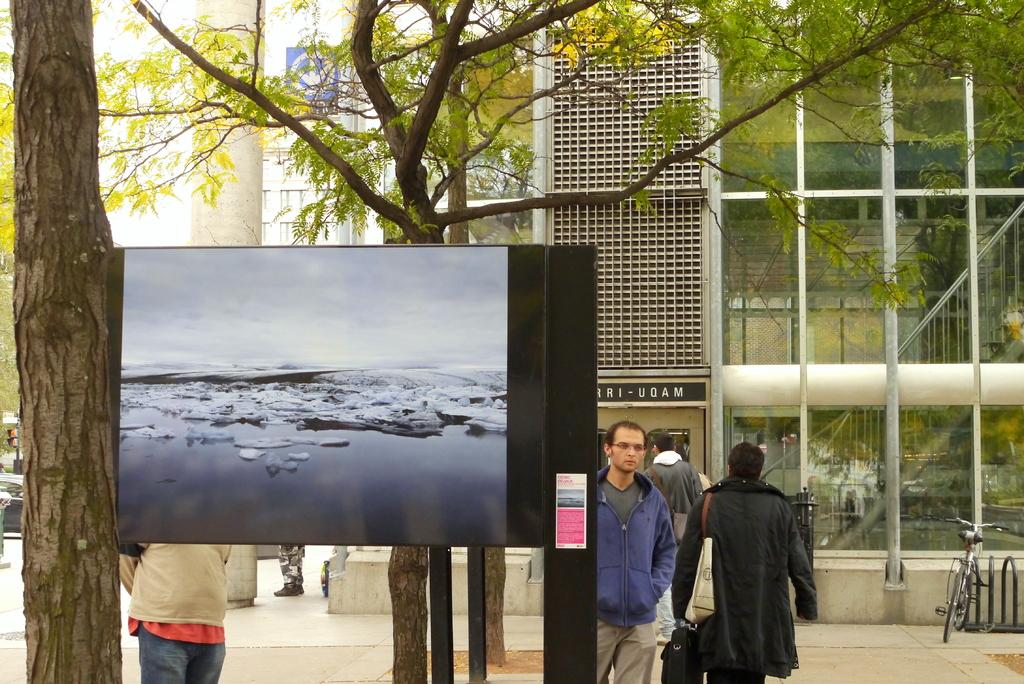How many people are in the image? There are people in the image, but the exact number is not specified. What is the board used for in the image? The purpose of the board in the image is not clear from the facts provided. What type of vegetation is present in the image? There are trees in the image. What mode of transportation is visible in the image? There is a bicycle in the image. What other objects are present in the image? There are rods in the image. What can be seen in the background of the image? There is a building and a vehicle in the background of the image, as well as another board on a wall. What type of juice is being served by the person in the image? There is no person or juice present in the image. What type of farming equipment can be seen in the image? There is no farming equipment present in the image. 